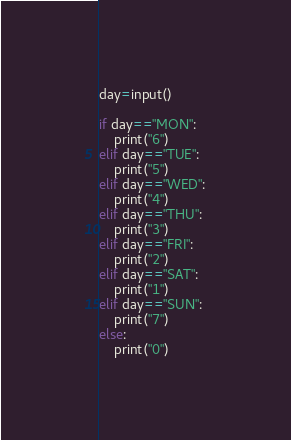Convert code to text. <code><loc_0><loc_0><loc_500><loc_500><_Python_>day=input()

if day=="MON":
	print("6")
elif day=="TUE":
	print("5")
elif day=="WED":
	print("4")
elif day=="THU":
	print("3")
elif day=="FRI":
	print("2")
elif day=="SAT":
	print("1")
elif day=="SUN":
	print("7")
else:
	print("0")</code> 